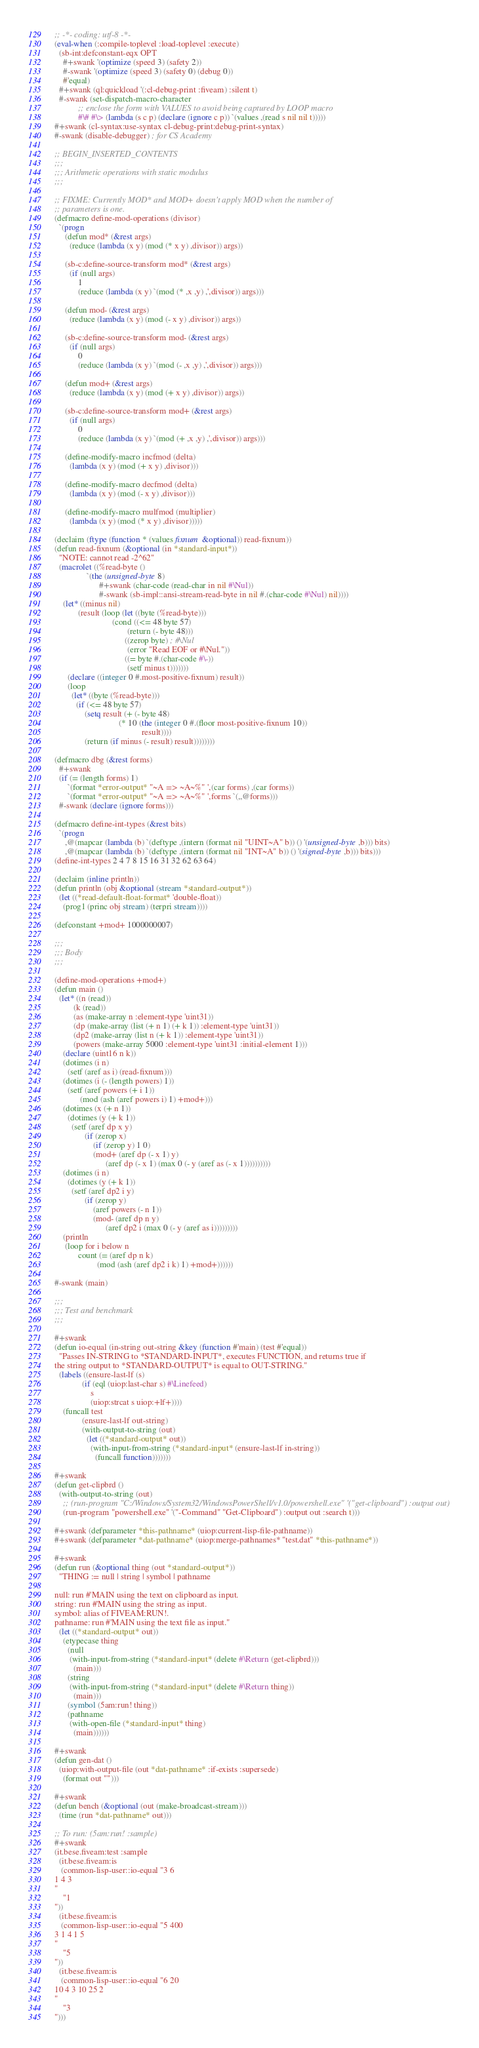<code> <loc_0><loc_0><loc_500><loc_500><_Lisp_>;; -*- coding: utf-8 -*-
(eval-when (:compile-toplevel :load-toplevel :execute)
  (sb-int:defconstant-eqx OPT
    #+swank '(optimize (speed 3) (safety 2))
    #-swank '(optimize (speed 3) (safety 0) (debug 0))
    #'equal)
  #+swank (ql:quickload '(:cl-debug-print :fiveam) :silent t)
  #-swank (set-dispatch-macro-character
           ;; enclose the form with VALUES to avoid being captured by LOOP macro
           #\# #\> (lambda (s c p) (declare (ignore c p)) `(values ,(read s nil nil t)))))
#+swank (cl-syntax:use-syntax cl-debug-print:debug-print-syntax)
#-swank (disable-debugger) ; for CS Academy

;; BEGIN_INSERTED_CONTENTS
;;;
;;; Arithmetic operations with static modulus
;;;

;; FIXME: Currently MOD* and MOD+ doesn't apply MOD when the number of
;; parameters is one.
(defmacro define-mod-operations (divisor)
  `(progn
     (defun mod* (&rest args)
       (reduce (lambda (x y) (mod (* x y) ,divisor)) args))

     (sb-c:define-source-transform mod* (&rest args)
       (if (null args)
           1
           (reduce (lambda (x y) `(mod (* ,x ,y) ,',divisor)) args)))

     (defun mod- (&rest args)
       (reduce (lambda (x y) (mod (- x y) ,divisor)) args))

     (sb-c:define-source-transform mod- (&rest args)
       (if (null args)
           0
           (reduce (lambda (x y) `(mod (- ,x ,y) ,',divisor)) args)))

     (defun mod+ (&rest args)
       (reduce (lambda (x y) (mod (+ x y) ,divisor)) args))

     (sb-c:define-source-transform mod+ (&rest args)
       (if (null args)
           0
           (reduce (lambda (x y) `(mod (+ ,x ,y) ,',divisor)) args)))

     (define-modify-macro incfmod (delta)
       (lambda (x y) (mod (+ x y) ,divisor)))

     (define-modify-macro decfmod (delta)
       (lambda (x y) (mod (- x y) ,divisor)))

     (define-modify-macro mulfmod (multiplier)
       (lambda (x y) (mod (* x y) ,divisor)))))

(declaim (ftype (function * (values fixnum &optional)) read-fixnum))
(defun read-fixnum (&optional (in *standard-input*))
  "NOTE: cannot read -2^62"
  (macrolet ((%read-byte ()
               `(the (unsigned-byte 8)
                     #+swank (char-code (read-char in nil #\Nul))
                     #-swank (sb-impl::ansi-stream-read-byte in nil #.(char-code #\Nul) nil))))
    (let* ((minus nil)
           (result (loop (let ((byte (%read-byte)))
                           (cond ((<= 48 byte 57)
                                  (return (- byte 48)))
                                 ((zerop byte) ; #\Nul
                                  (error "Read EOF or #\Nul."))
                                 ((= byte #.(char-code #\-))
                                  (setf minus t)))))))
      (declare ((integer 0 #.most-positive-fixnum) result))
      (loop
        (let* ((byte (%read-byte)))
          (if (<= 48 byte 57)
              (setq result (+ (- byte 48)
                              (* 10 (the (integer 0 #.(floor most-positive-fixnum 10))
                                         result))))
              (return (if minus (- result) result))))))))

(defmacro dbg (&rest forms)
  #+swank
  (if (= (length forms) 1)
      `(format *error-output* "~A => ~A~%" ',(car forms) ,(car forms))
      `(format *error-output* "~A => ~A~%" ',forms `(,,@forms)))
  #-swank (declare (ignore forms)))

(defmacro define-int-types (&rest bits)
  `(progn
     ,@(mapcar (lambda (b) `(deftype ,(intern (format nil "UINT~A" b)) () '(unsigned-byte ,b))) bits)
     ,@(mapcar (lambda (b) `(deftype ,(intern (format nil "INT~A" b)) () '(signed-byte ,b))) bits)))
(define-int-types 2 4 7 8 15 16 31 32 62 63 64)

(declaim (inline println))
(defun println (obj &optional (stream *standard-output*))
  (let ((*read-default-float-format* 'double-float))
    (prog1 (princ obj stream) (terpri stream))))

(defconstant +mod+ 1000000007)

;;;
;;; Body
;;;

(define-mod-operations +mod+)
(defun main ()
  (let* ((n (read))
         (k (read))
         (as (make-array n :element-type 'uint31))
         (dp (make-array (list (+ n 1) (+ k 1)) :element-type 'uint31))
         (dp2 (make-array (list n (+ k 1)) :element-type 'uint31))
         (powers (make-array 5000 :element-type 'uint31 :initial-element 1)))
    (declare (uint16 n k))
    (dotimes (i n)
      (setf (aref as i) (read-fixnum)))
    (dotimes (i (- (length powers) 1))
      (setf (aref powers (+ i 1))
            (mod (ash (aref powers i) 1) +mod+)))
    (dotimes (x (+ n 1))
      (dotimes (y (+ k 1))
        (setf (aref dp x y)
              (if (zerop x)
                  (if (zerop y) 1 0)
                  (mod+ (aref dp (- x 1) y)
                        (aref dp (- x 1) (max 0 (- y (aref as (- x 1))))))))))
    (dotimes (i n)
      (dotimes (y (+ k 1))
        (setf (aref dp2 i y)
              (if (zerop y)
                  (aref powers (- n 1))
                  (mod- (aref dp n y)
                        (aref dp2 i (max 0 (- y (aref as i)))))))))
    (println
     (loop for i below n
           count (= (aref dp n k)
                    (mod (ash (aref dp2 i k) 1) +mod+))))))

#-swank (main)

;;;
;;; Test and benchmark
;;;

#+swank
(defun io-equal (in-string out-string &key (function #'main) (test #'equal))
  "Passes IN-STRING to *STANDARD-INPUT*, executes FUNCTION, and returns true if
the string output to *STANDARD-OUTPUT* is equal to OUT-STRING."
  (labels ((ensure-last-lf (s)
             (if (eql (uiop:last-char s) #\Linefeed)
                 s
                 (uiop:strcat s uiop:+lf+))))
    (funcall test
             (ensure-last-lf out-string)
             (with-output-to-string (out)
               (let ((*standard-output* out))
                 (with-input-from-string (*standard-input* (ensure-last-lf in-string))
                   (funcall function)))))))

#+swank
(defun get-clipbrd ()
  (with-output-to-string (out)
    ;; (run-program "C:/Windows/System32/WindowsPowerShell/v1.0/powershell.exe" '("get-clipboard") :output out)
    (run-program "powershell.exe" '("-Command" "Get-Clipboard") :output out :search t)))

#+swank (defparameter *this-pathname* (uiop:current-lisp-file-pathname))
#+swank (defparameter *dat-pathname* (uiop:merge-pathnames* "test.dat" *this-pathname*))

#+swank
(defun run (&optional thing (out *standard-output*))
  "THING := null | string | symbol | pathname

null: run #'MAIN using the text on clipboard as input.
string: run #'MAIN using the string as input.
symbol: alias of FIVEAM:RUN!.
pathname: run #'MAIN using the text file as input."
  (let ((*standard-output* out))
    (etypecase thing
      (null
       (with-input-from-string (*standard-input* (delete #\Return (get-clipbrd)))
         (main)))
      (string
       (with-input-from-string (*standard-input* (delete #\Return thing))
         (main)))
      (symbol (5am:run! thing))
      (pathname
       (with-open-file (*standard-input* thing)
         (main))))))

#+swank
(defun gen-dat ()
  (uiop:with-output-file (out *dat-pathname* :if-exists :supersede)
    (format out "")))

#+swank
(defun bench (&optional (out (make-broadcast-stream)))
  (time (run *dat-pathname* out)))

;; To run: (5am:run! :sample)
#+swank
(it.bese.fiveam:test :sample
  (it.bese.fiveam:is
   (common-lisp-user::io-equal "3 6
1 4 3
"
    "1
"))
  (it.bese.fiveam:is
   (common-lisp-user::io-equal "5 400
3 1 4 1 5
"
    "5
"))
  (it.bese.fiveam:is
   (common-lisp-user::io-equal "6 20
10 4 3 10 25 2
"
    "3
")))
</code> 